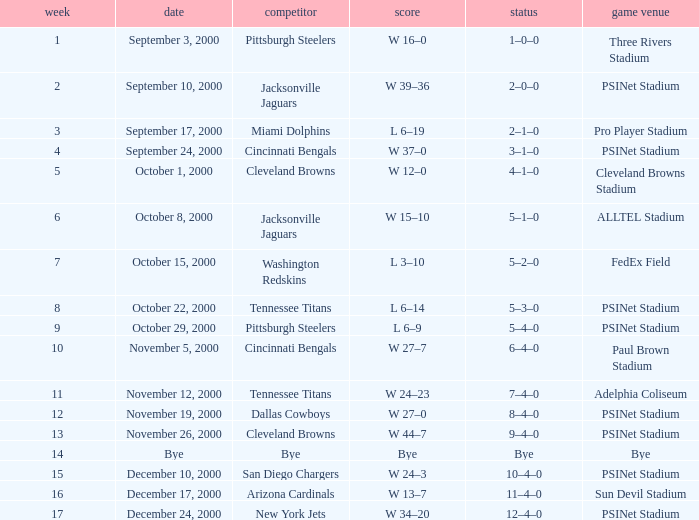What's the result at psinet stadium when the cincinnati bengals are the opponent? W 37–0. Give me the full table as a dictionary. {'header': ['week', 'date', 'competitor', 'score', 'status', 'game venue'], 'rows': [['1', 'September 3, 2000', 'Pittsburgh Steelers', 'W 16–0', '1–0–0', 'Three Rivers Stadium'], ['2', 'September 10, 2000', 'Jacksonville Jaguars', 'W 39–36', '2–0–0', 'PSINet Stadium'], ['3', 'September 17, 2000', 'Miami Dolphins', 'L 6–19', '2–1–0', 'Pro Player Stadium'], ['4', 'September 24, 2000', 'Cincinnati Bengals', 'W 37–0', '3–1–0', 'PSINet Stadium'], ['5', 'October 1, 2000', 'Cleveland Browns', 'W 12–0', '4–1–0', 'Cleveland Browns Stadium'], ['6', 'October 8, 2000', 'Jacksonville Jaguars', 'W 15–10', '5–1–0', 'ALLTEL Stadium'], ['7', 'October 15, 2000', 'Washington Redskins', 'L 3–10', '5–2–0', 'FedEx Field'], ['8', 'October 22, 2000', 'Tennessee Titans', 'L 6–14', '5–3–0', 'PSINet Stadium'], ['9', 'October 29, 2000', 'Pittsburgh Steelers', 'L 6–9', '5–4–0', 'PSINet Stadium'], ['10', 'November 5, 2000', 'Cincinnati Bengals', 'W 27–7', '6–4–0', 'Paul Brown Stadium'], ['11', 'November 12, 2000', 'Tennessee Titans', 'W 24–23', '7–4–0', 'Adelphia Coliseum'], ['12', 'November 19, 2000', 'Dallas Cowboys', 'W 27–0', '8–4–0', 'PSINet Stadium'], ['13', 'November 26, 2000', 'Cleveland Browns', 'W 44–7', '9–4–0', 'PSINet Stadium'], ['14', 'Bye', 'Bye', 'Bye', 'Bye', 'Bye'], ['15', 'December 10, 2000', 'San Diego Chargers', 'W 24–3', '10–4–0', 'PSINet Stadium'], ['16', 'December 17, 2000', 'Arizona Cardinals', 'W 13–7', '11–4–0', 'Sun Devil Stadium'], ['17', 'December 24, 2000', 'New York Jets', 'W 34–20', '12–4–0', 'PSINet Stadium']]} 